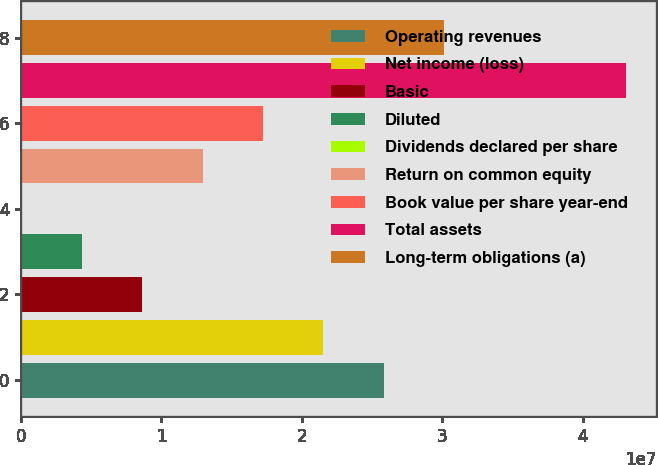Convert chart. <chart><loc_0><loc_0><loc_500><loc_500><bar_chart><fcel>Operating revenues<fcel>Net income (loss)<fcel>Basic<fcel>Diluted<fcel>Dividends declared per share<fcel>Return on common equity<fcel>Book value per share year-end<fcel>Total assets<fcel>Long-term obligations (a)<nl><fcel>2.58524e+07<fcel>2.15437e+07<fcel>8.61747e+06<fcel>4.30874e+06<fcel>3.32<fcel>1.29262e+07<fcel>1.72349e+07<fcel>4.30873e+07<fcel>3.01611e+07<nl></chart> 